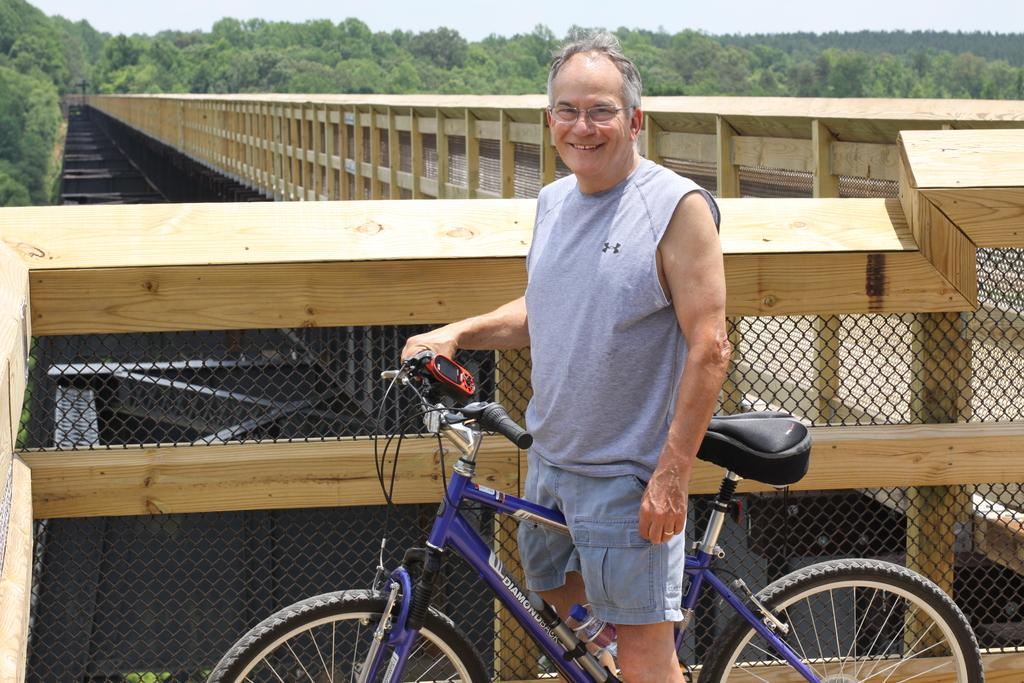What is the main subject of the image? The main subject of the image is a man. What is the man wearing in the image? The man is wearing a grey t-shirt in the image. What is the man doing in the image? The man is standing on a bicycle in the image. What type of eyewear is the man wearing in the image? The man is wearing spectacles in the image. What is the man's facial expression in the image? The man is smiling in the image. Where is the man standing in the image? The man is standing on a bridge in the image. What can be seen in the background of the image? Trees and the sky are visible in the background of the image. What type of skirt is the man wearing in the image? The man is not wearing a skirt in the image; he is wearing a grey t-shirt. 